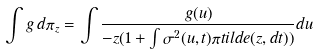Convert formula to latex. <formula><loc_0><loc_0><loc_500><loc_500>\int g \, d \pi _ { z } = \int \frac { g ( u ) } { - z ( 1 + \int \sigma ^ { 2 } ( u , t ) \pi t i l d e ( z , d t ) ) } d u</formula> 